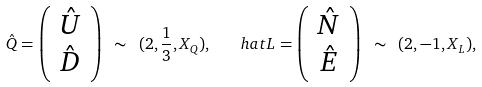<formula> <loc_0><loc_0><loc_500><loc_500>\hat { Q } = \left ( \begin{array} { c } \hat { U } \\ \hat { D } \end{array} \right ) \ \sim \ ( 2 , \frac { 1 } { 3 } , X _ { Q } ) , \quad h a t { L } = \left ( \begin{array} { c } \hat { N } \\ \hat { E } \end{array} \right ) \ \sim \ ( 2 , - 1 , X _ { L } ) ,</formula> 